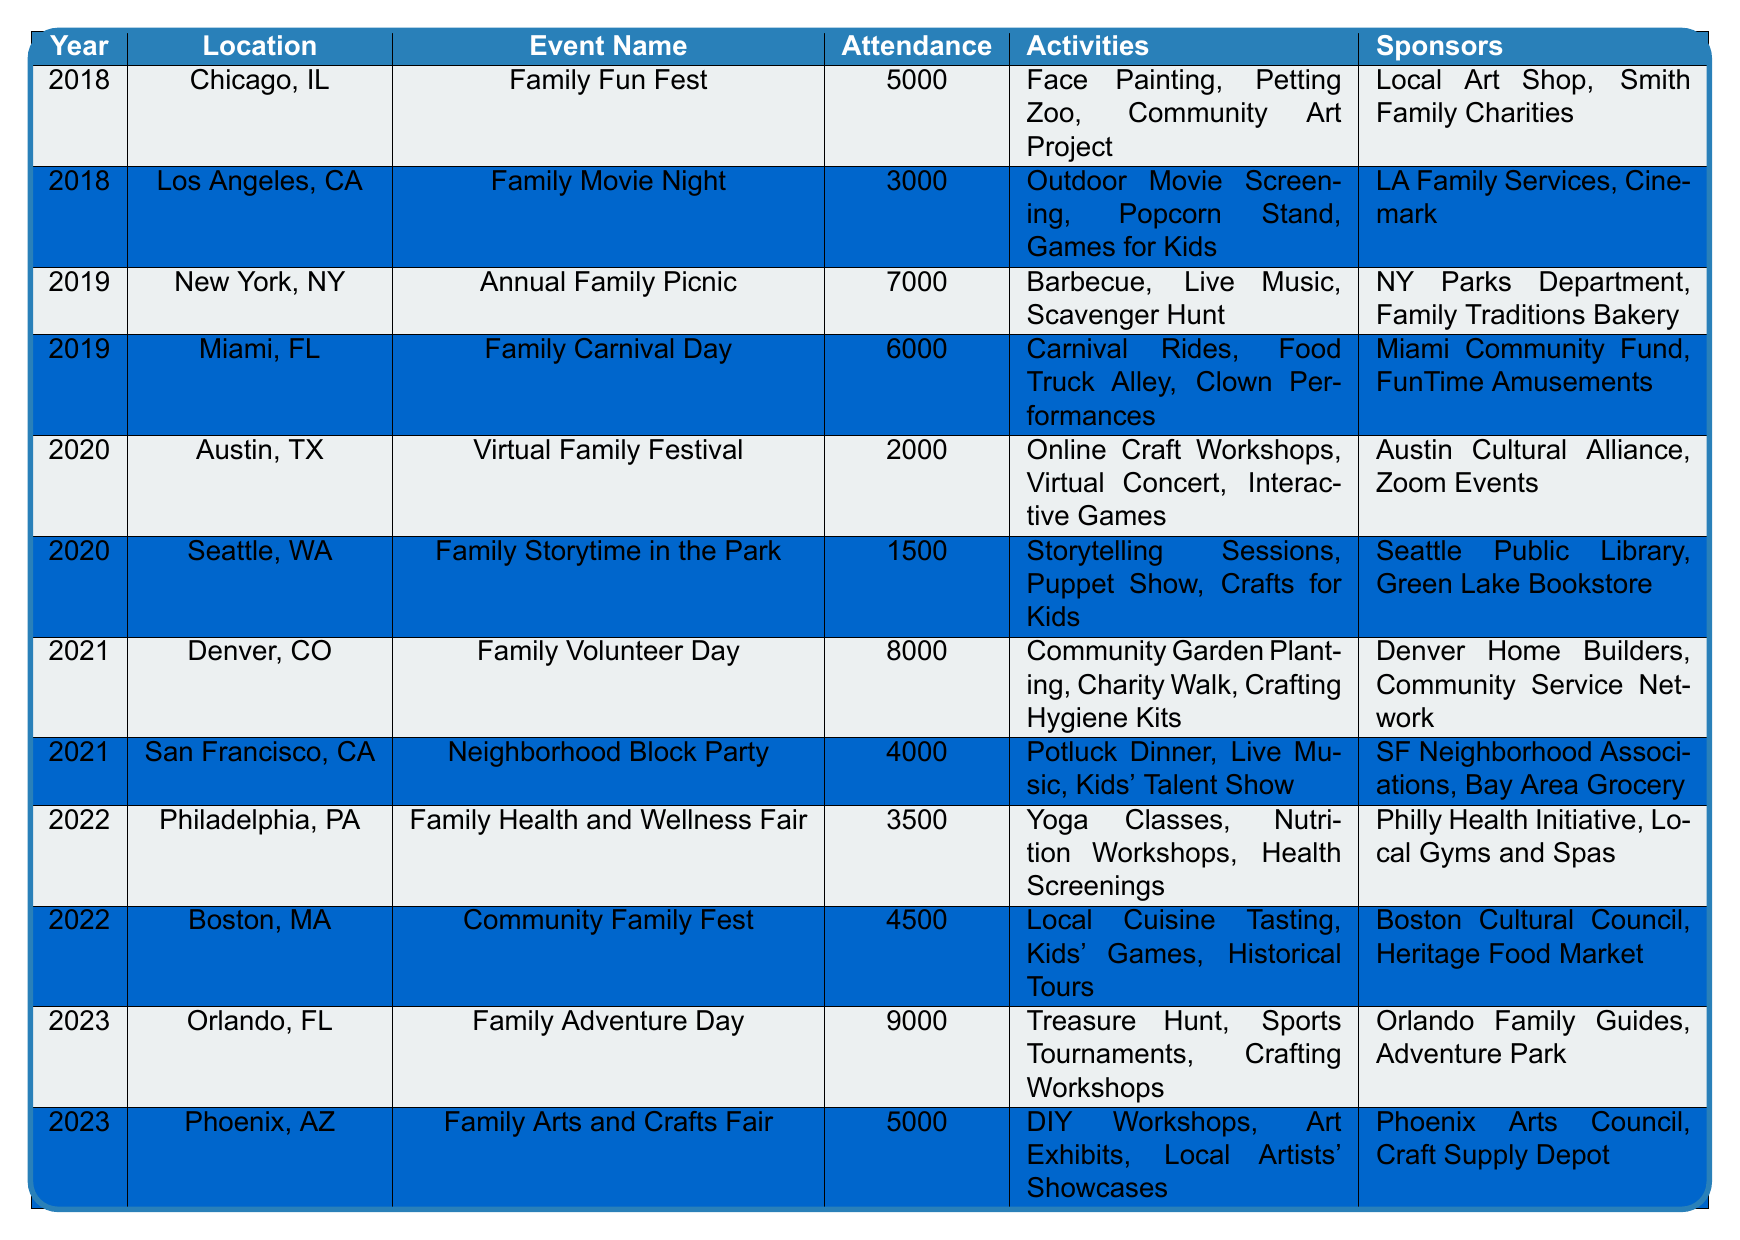What was the highest attendance recorded for a family community event? Only the event with the highest attendance is needed. Looking through the table, the Family Adventure Day in Orlando, FL, in 2023 had an attendance of 9000, which is the highest.
Answer: 9000 Which event had the lowest attendance, and what was the attendance number? The event with the lowest attendance is Family Storytime in the Park in Seattle, WA, 2020, with an attendance of 1500.
Answer: 1500 In which year did the Family Health and Wellness Fair take place? The Family Health and Wellness Fair occurred in 2022, as indicated in the table.
Answer: 2022 How many events were held in 2021, and what were their names? There are two events in 2021: Family Volunteer Day in Denver, CO, and Neighborhood Block Party in San Francisco, CA.
Answer: 2 events: Family Volunteer Day, Neighborhood Block Party What is the average attendance for family community events in 2019? Adding the attendances for the two events in 2019: 7000 (Annual Family Picnic) + 6000 (Family Carnival Day) = 13000. Then divide by 2 (the number of events) to get the average: 13000 / 2 = 6500.
Answer: 6500 How many different types of activities were listed for the Family Fun Fest in Chicago? The Family Fun Fest included three activities: Face Painting, Petting Zoo, and Community Art Project. Counting these gives a total of three activities.
Answer: 3 Which location hosted a family event with sponsors from local businesses? The Family Fun Fest in Chicago, IL, featured sponsors from local companies: Local Art Shop and Smith Family Charities.
Answer: Chicago, IL Was there an event held virtually in 2020, and if so, what was its attendance? Yes, the Virtual Family Festival in Austin, TX, was held in 2020 with an attendance of 2000.
Answer: Yes, attendance was 2000 What was the combined attendance for events in 2022? The attendance for both events in 2022 is 3500 (Family Health and Wellness Fair) + 4500 (Community Family Fest) = 8000, so the combined attendance is 8000.
Answer: 8000 Was there a family community event in Phoenix, AZ, in 2023? Yes, the Family Arts and Crafts Fair was held in Phoenix, AZ, in 2023 as indicated in the table.
Answer: Yes 